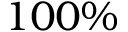<formula> <loc_0><loc_0><loc_500><loc_500>1 0 0 \%</formula> 